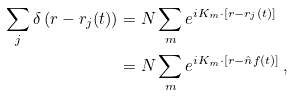Convert formula to latex. <formula><loc_0><loc_0><loc_500><loc_500>\sum _ { j } \delta \left ( r - r _ { j } ( t ) \right ) & = N \sum _ { m } e ^ { i K _ { m } \cdot \left [ r - r _ { j } ( t ) \right ] } \\ & = N \sum _ { m } e ^ { i K _ { m } \cdot \left [ r - \hat { n } f ( t ) \right ] } \, ,</formula> 